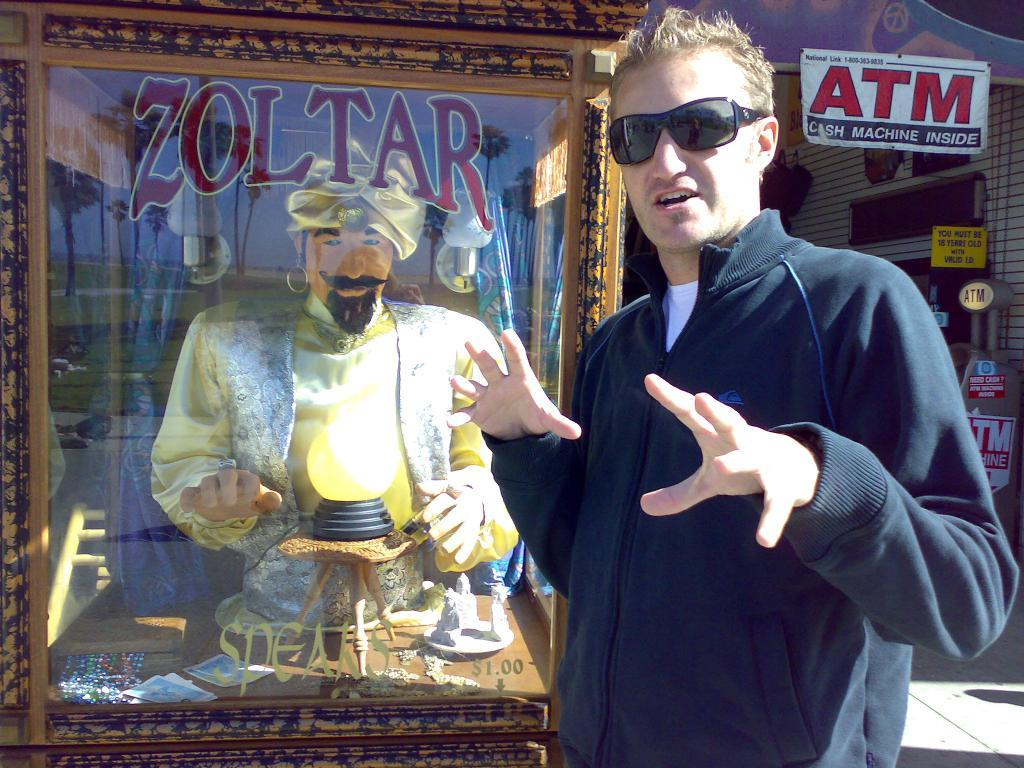What is the position of the man in the image? There is a man standing on the right side of the image. What accessory is the man wearing? The man is wearing glasses. Who is standing next to the man? There is a fortune teller next to the man. What can be seen in the background of the image? There are boards visible in the background of the image. How many cats are sitting on the fortune teller's lap in the image? There are no cats present in the image; it features a man and a fortune teller. What is the man's digestion process like in the image? There is no information about the man's digestion process in the image. 